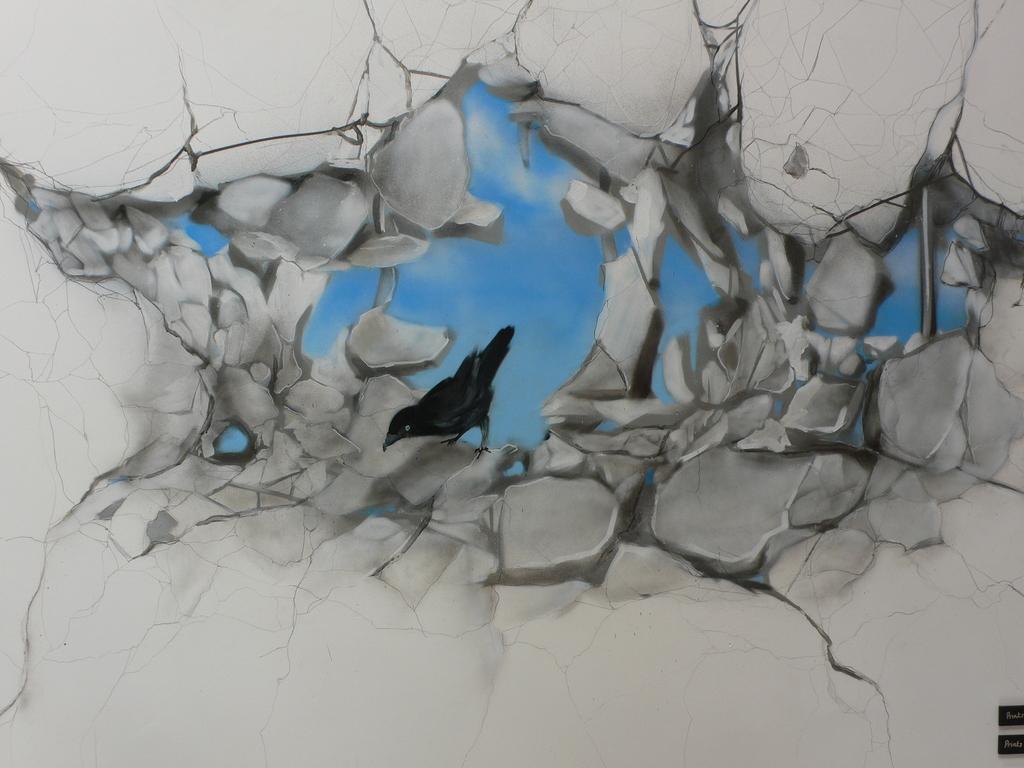How would you summarize this image in a sentence or two? This image consists of a bird in the middle. There is the sky in the middle. Bird is in black color. 